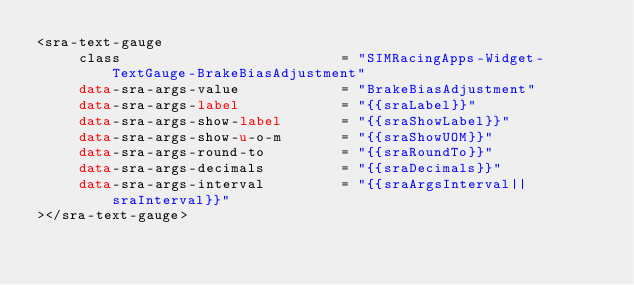Convert code to text. <code><loc_0><loc_0><loc_500><loc_500><_HTML_><sra-text-gauge
     class                          = "SIMRacingApps-Widget-TextGauge-BrakeBiasAdjustment"
     data-sra-args-value            = "BrakeBiasAdjustment"
     data-sra-args-label            = "{{sraLabel}}"
     data-sra-args-show-label       = "{{sraShowLabel}}"
     data-sra-args-show-u-o-m       = "{{sraShowUOM}}"
     data-sra-args-round-to         = "{{sraRoundTo}}"
     data-sra-args-decimals         = "{{sraDecimals}}"
     data-sra-args-interval         = "{{sraArgsInterval||sraInterval}}"
></sra-text-gauge>
</code> 